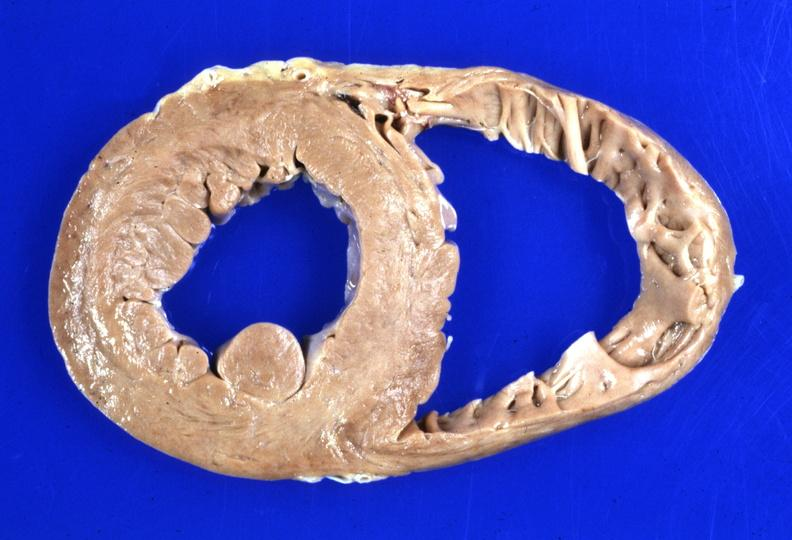s cardiovascular present?
Answer the question using a single word or phrase. Yes 